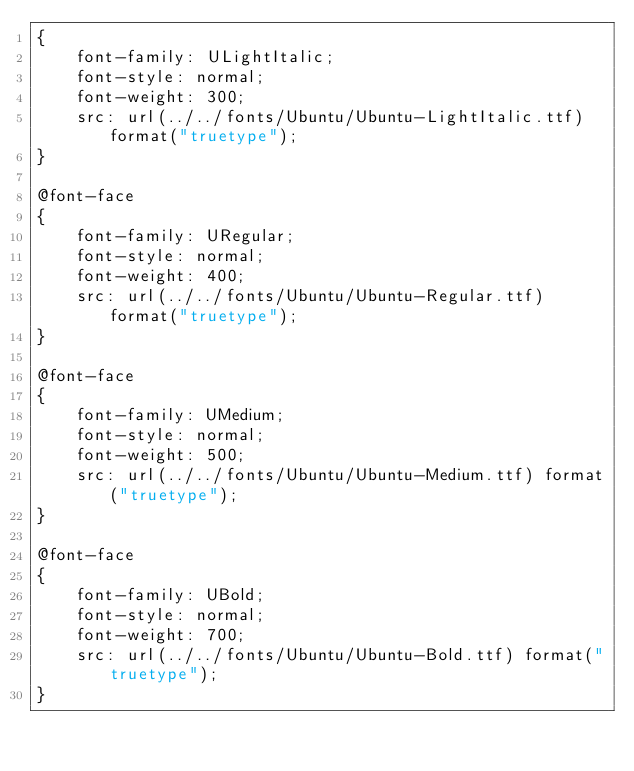Convert code to text. <code><loc_0><loc_0><loc_500><loc_500><_CSS_>{
	font-family: ULightItalic;
	font-style: normal;
	font-weight: 300;
	src: url(../../fonts/Ubuntu/Ubuntu-LightItalic.ttf) format("truetype");
}

@font-face
{
	font-family: URegular;
	font-style: normal;
	font-weight: 400;
	src: url(../../fonts/Ubuntu/Ubuntu-Regular.ttf) format("truetype");
}

@font-face
{
	font-family: UMedium;
	font-style: normal;
	font-weight: 500;
	src: url(../../fonts/Ubuntu/Ubuntu-Medium.ttf) format("truetype");
}

@font-face
{
	font-family: UBold;
	font-style: normal;
	font-weight: 700;
	src: url(../../fonts/Ubuntu/Ubuntu-Bold.ttf) format("truetype");
}</code> 